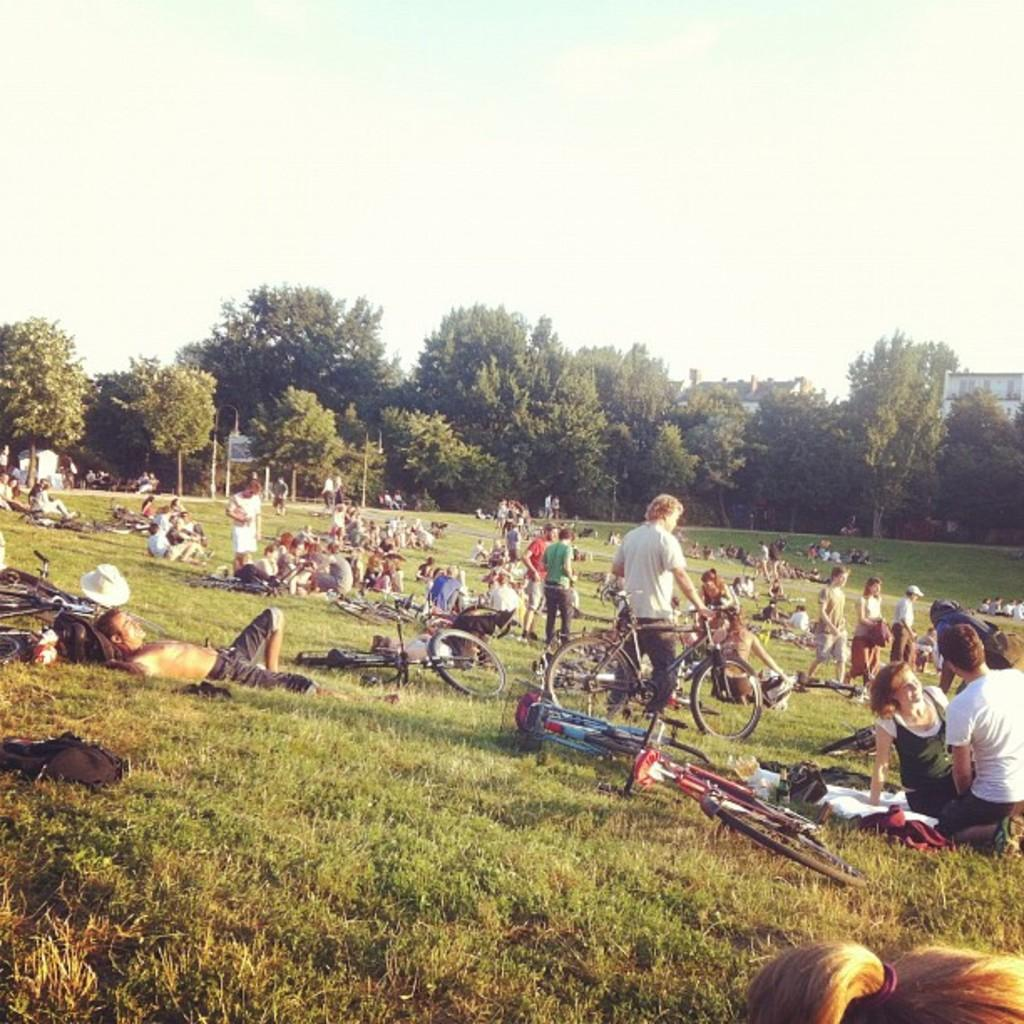How many people are present in the image? There are many people in the image. What objects are on the ground in the image? There are bicycles on the ground in the image. What can be seen in the background of the image? There are trees, buildings, poles, and boards in the background of the image. What is visible at the top of the image? The sky is visible at the top of the image. What type of shoe is being worn by the person in the image? There is no specific person mentioned in the image, and no shoes are visible, so it is not possible to determine the type of shoe being worn. 